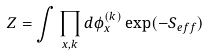Convert formula to latex. <formula><loc_0><loc_0><loc_500><loc_500>Z = \int \prod _ { x , k } d \phi ^ { ( k ) } _ { x } \exp ( - S _ { e f f } )</formula> 